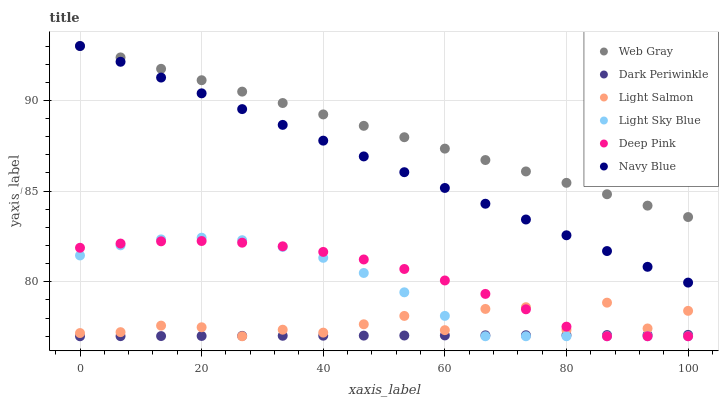Does Dark Periwinkle have the minimum area under the curve?
Answer yes or no. Yes. Does Web Gray have the maximum area under the curve?
Answer yes or no. Yes. Does Navy Blue have the minimum area under the curve?
Answer yes or no. No. Does Navy Blue have the maximum area under the curve?
Answer yes or no. No. Is Web Gray the smoothest?
Answer yes or no. Yes. Is Light Salmon the roughest?
Answer yes or no. Yes. Is Navy Blue the smoothest?
Answer yes or no. No. Is Navy Blue the roughest?
Answer yes or no. No. Does Light Salmon have the lowest value?
Answer yes or no. Yes. Does Navy Blue have the lowest value?
Answer yes or no. No. Does Navy Blue have the highest value?
Answer yes or no. Yes. Does Deep Pink have the highest value?
Answer yes or no. No. Is Deep Pink less than Web Gray?
Answer yes or no. Yes. Is Web Gray greater than Dark Periwinkle?
Answer yes or no. Yes. Does Web Gray intersect Navy Blue?
Answer yes or no. Yes. Is Web Gray less than Navy Blue?
Answer yes or no. No. Is Web Gray greater than Navy Blue?
Answer yes or no. No. Does Deep Pink intersect Web Gray?
Answer yes or no. No. 